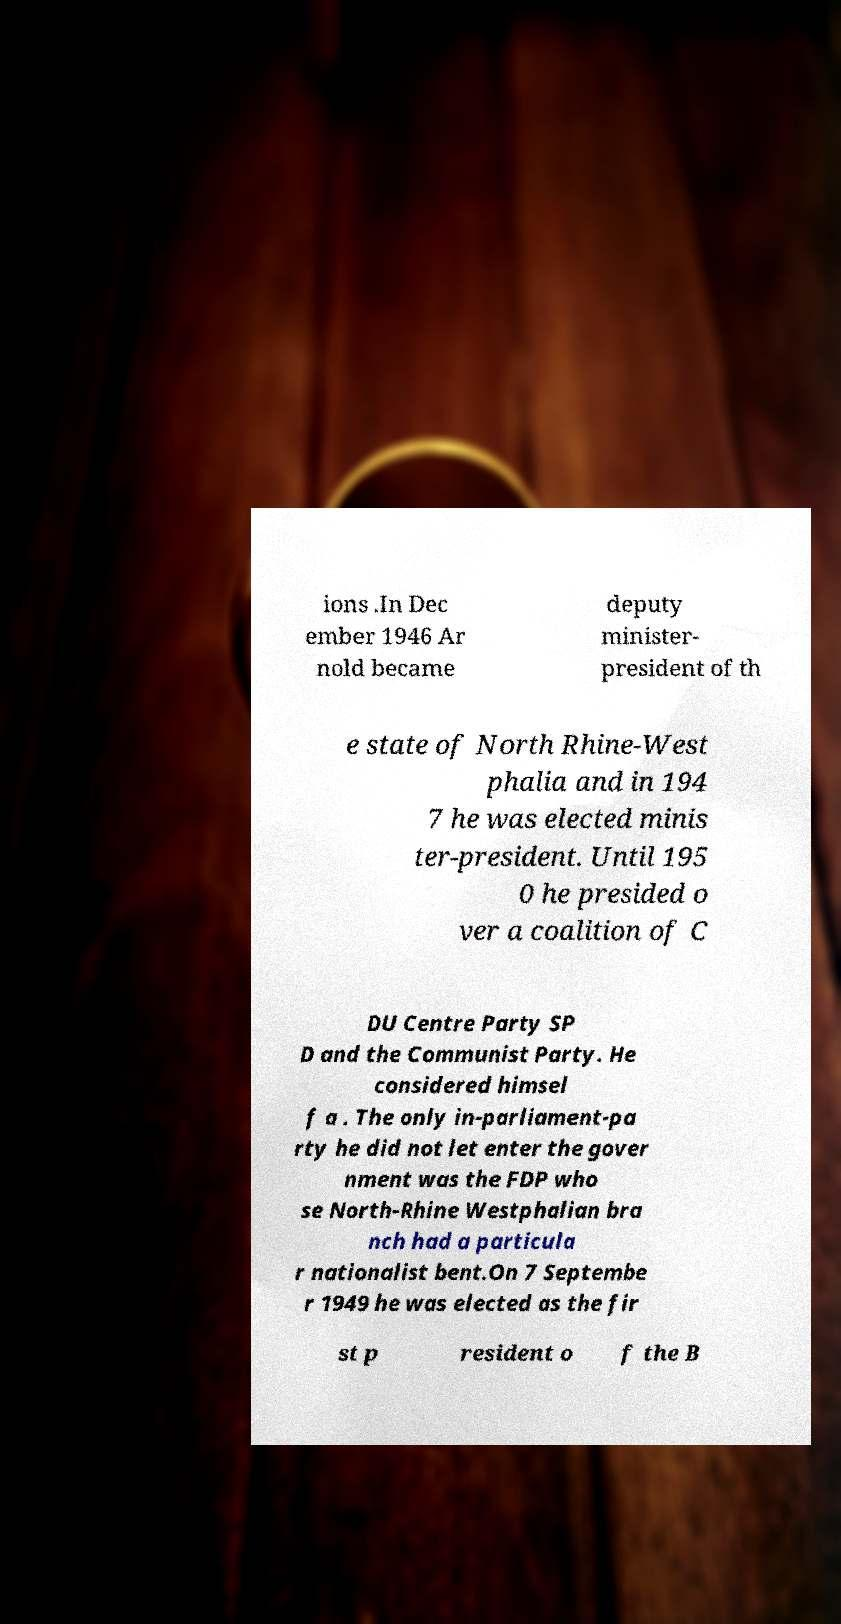Could you assist in decoding the text presented in this image and type it out clearly? ions .In Dec ember 1946 Ar nold became deputy minister- president of th e state of North Rhine-West phalia and in 194 7 he was elected minis ter-president. Until 195 0 he presided o ver a coalition of C DU Centre Party SP D and the Communist Party. He considered himsel f a . The only in-parliament-pa rty he did not let enter the gover nment was the FDP who se North-Rhine Westphalian bra nch had a particula r nationalist bent.On 7 Septembe r 1949 he was elected as the fir st p resident o f the B 